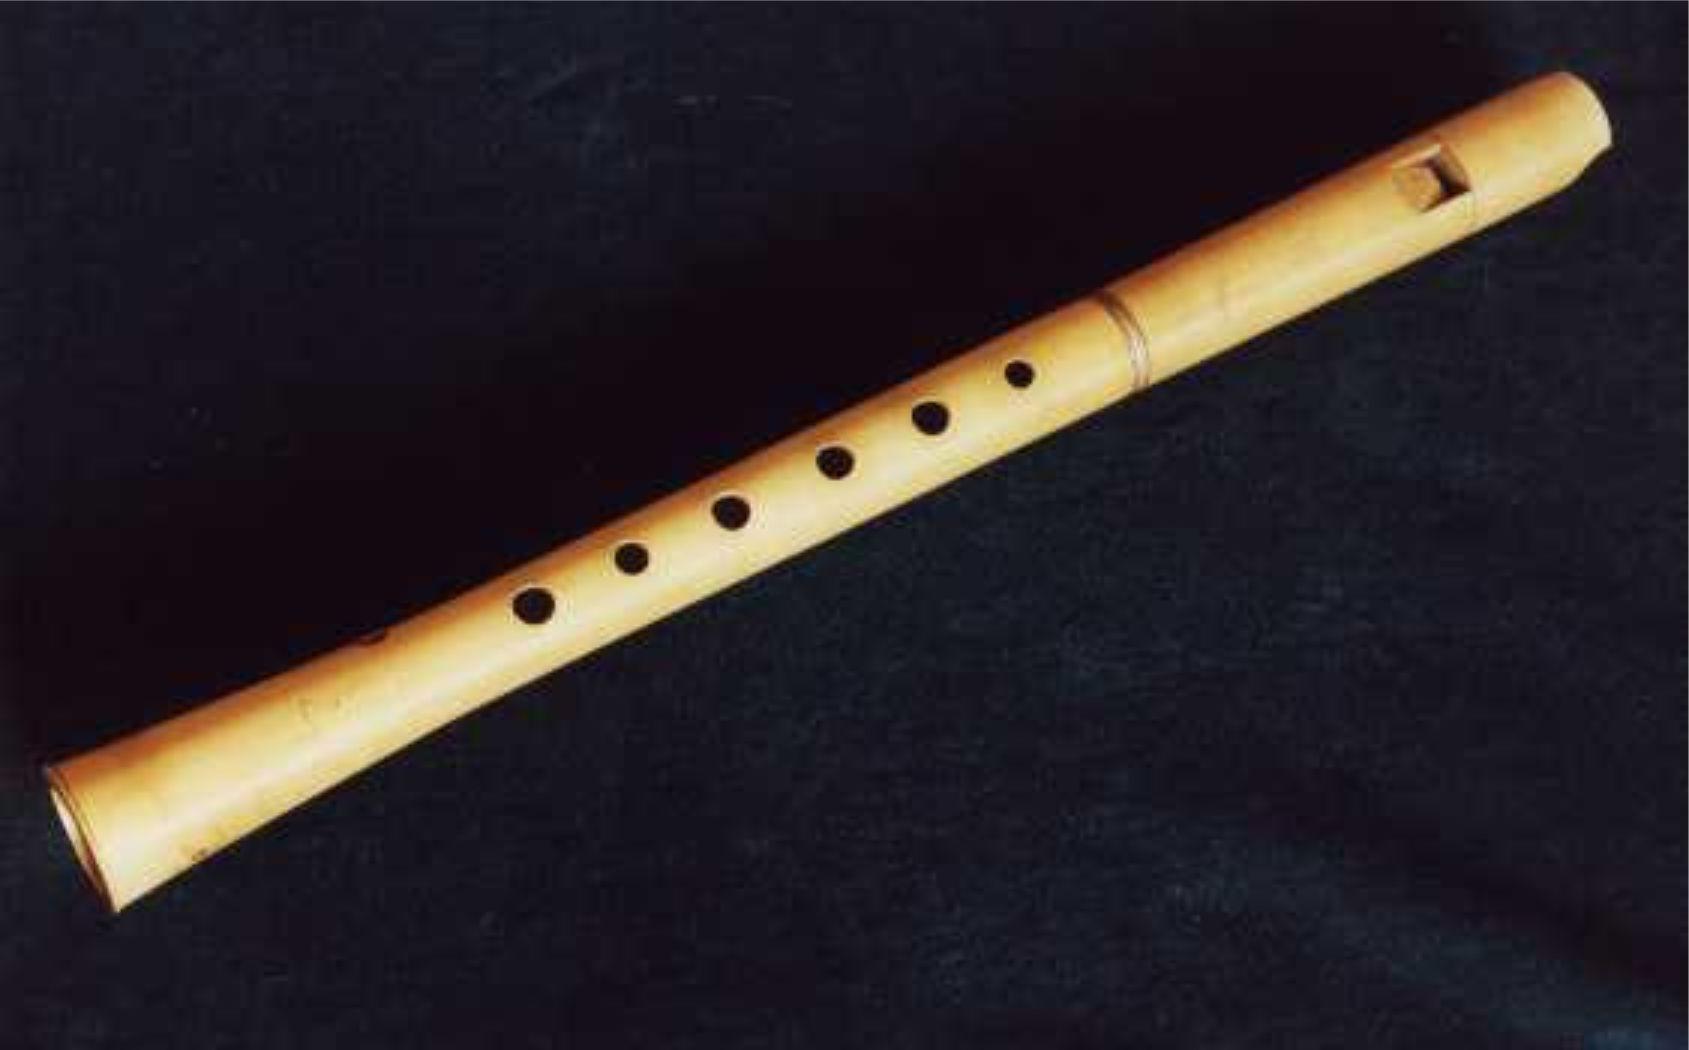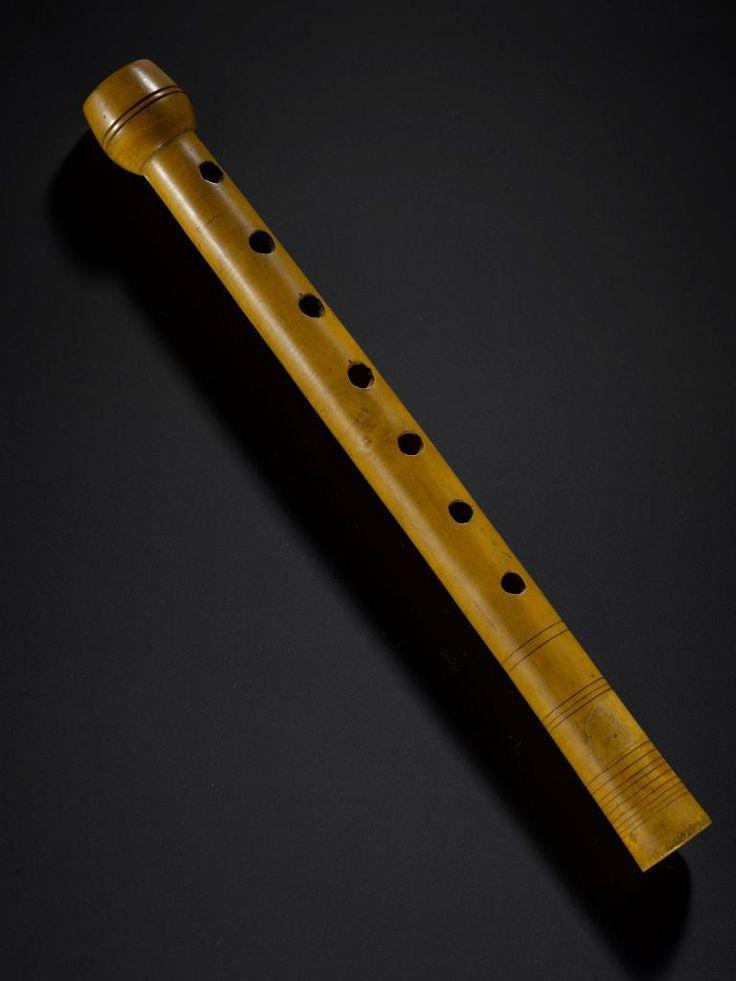The first image is the image on the left, the second image is the image on the right. For the images displayed, is the sentence "There are more than three instruments in at least one of the images." factually correct? Answer yes or no. No. The first image is the image on the left, the second image is the image on the right. Given the left and right images, does the statement "One image shows at least four flutes arranged in a row but not perfectly parallel to one another." hold true? Answer yes or no. No. 